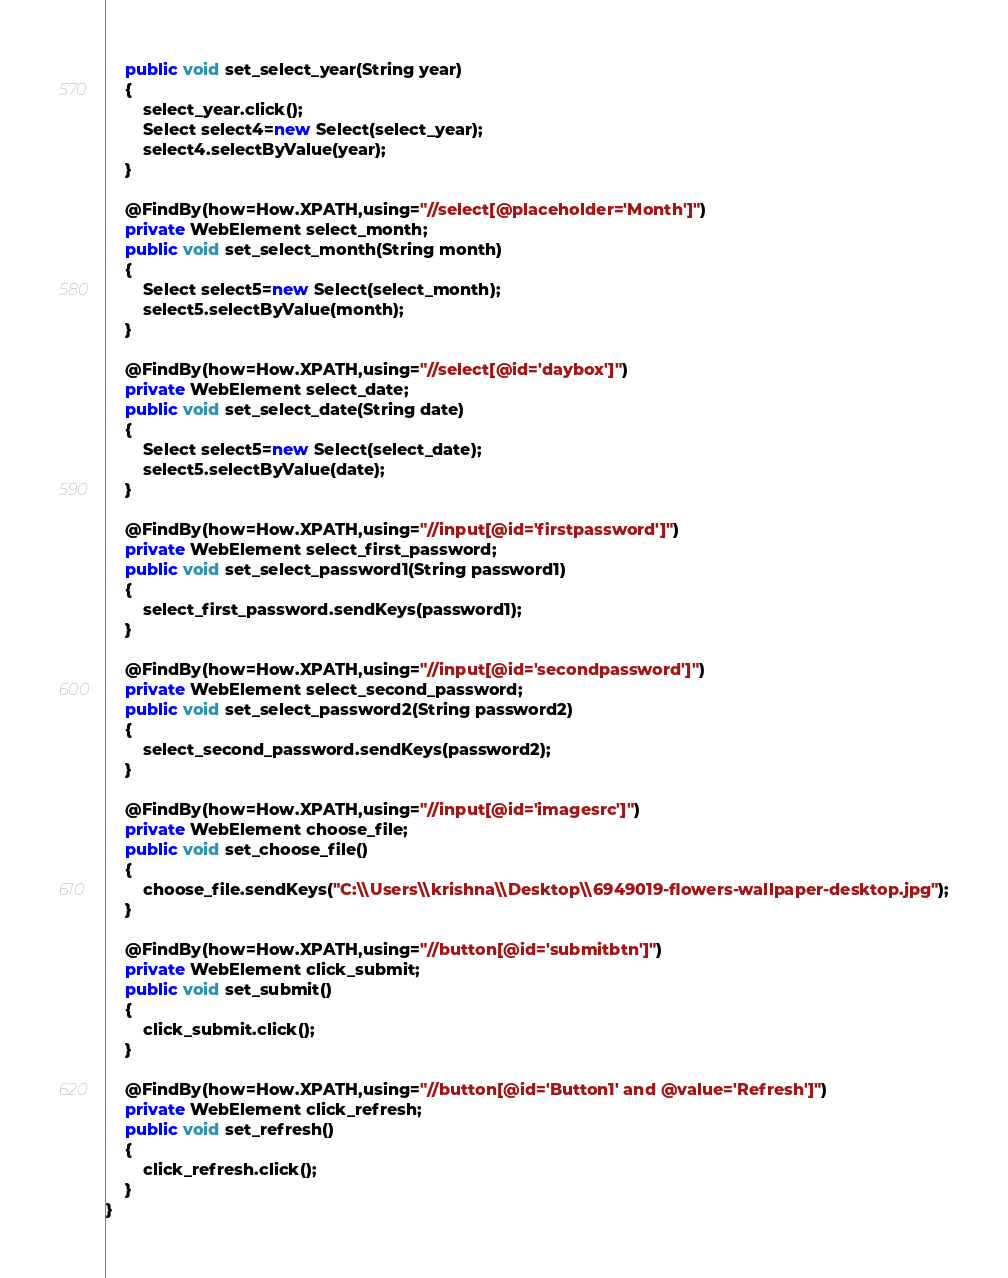<code> <loc_0><loc_0><loc_500><loc_500><_Java_>    public void set_select_year(String year)
	{
    	select_year.click();
		Select select4=new Select(select_year);
		select4.selectByValue(year);
	}
    
    @FindBy(how=How.XPATH,using="//select[@placeholder='Month']")
    private WebElement select_month;
    public void set_select_month(String month)
	{
		Select select5=new Select(select_month);
		select5.selectByValue(month);
	}
    
    @FindBy(how=How.XPATH,using="//select[@id='daybox']")
    private WebElement select_date;
    public void set_select_date(String date)
	{
		Select select5=new Select(select_date);
		select5.selectByValue(date);
	}
    
    @FindBy(how=How.XPATH,using="//input[@id='firstpassword']")
    private WebElement select_first_password;
    public void set_select_password1(String password1)
	{
    	select_first_password.sendKeys(password1);
	}
    
    @FindBy(how=How.XPATH,using="//input[@id='secondpassword']")
    private WebElement select_second_password;
    public void set_select_password2(String password2)
	{
    	select_second_password.sendKeys(password2);
	}
    
    @FindBy(how=How.XPATH,using="//input[@id='imagesrc']")
    private WebElement choose_file;
    public void set_choose_file()
    {
    	choose_file.sendKeys("C:\\Users\\krishna\\Desktop\\6949019-flowers-wallpaper-desktop.jpg");
    }
    
    @FindBy(how=How.XPATH,using="//button[@id='submitbtn']")
    private WebElement click_submit;
    public void set_submit()
	{
    	click_submit.click();
	}
    
    @FindBy(how=How.XPATH,using="//button[@id='Button1' and @value='Refresh']")
    private WebElement click_refresh;
    public void set_refresh()
	{
    	click_refresh.click();
	}
}
</code> 